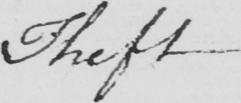What text is written in this handwritten line? Theft 